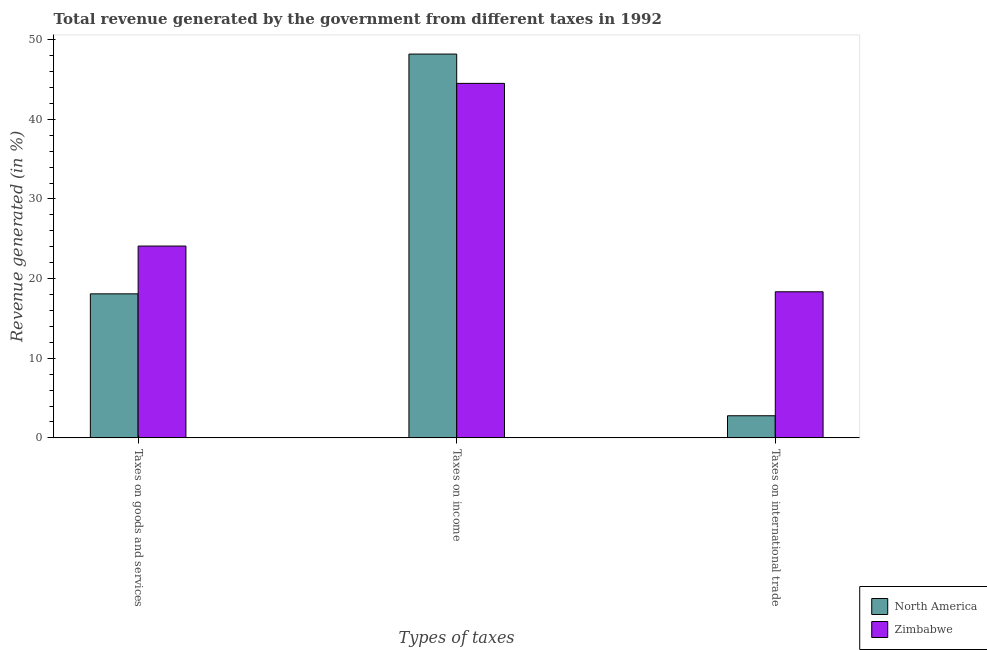Are the number of bars per tick equal to the number of legend labels?
Keep it short and to the point. Yes. Are the number of bars on each tick of the X-axis equal?
Keep it short and to the point. Yes. How many bars are there on the 2nd tick from the left?
Ensure brevity in your answer.  2. How many bars are there on the 1st tick from the right?
Your response must be concise. 2. What is the label of the 1st group of bars from the left?
Offer a very short reply. Taxes on goods and services. What is the percentage of revenue generated by taxes on income in Zimbabwe?
Offer a terse response. 44.51. Across all countries, what is the maximum percentage of revenue generated by taxes on goods and services?
Your answer should be very brief. 24.08. Across all countries, what is the minimum percentage of revenue generated by taxes on income?
Provide a succinct answer. 44.51. In which country was the percentage of revenue generated by taxes on goods and services minimum?
Offer a very short reply. North America. What is the total percentage of revenue generated by tax on international trade in the graph?
Your response must be concise. 21.12. What is the difference between the percentage of revenue generated by taxes on goods and services in Zimbabwe and that in North America?
Provide a succinct answer. 6. What is the difference between the percentage of revenue generated by tax on international trade in Zimbabwe and the percentage of revenue generated by taxes on goods and services in North America?
Make the answer very short. 0.26. What is the average percentage of revenue generated by tax on international trade per country?
Make the answer very short. 10.56. What is the difference between the percentage of revenue generated by taxes on income and percentage of revenue generated by taxes on goods and services in Zimbabwe?
Offer a very short reply. 20.43. What is the ratio of the percentage of revenue generated by tax on international trade in North America to that in Zimbabwe?
Provide a short and direct response. 0.15. Is the percentage of revenue generated by taxes on goods and services in North America less than that in Zimbabwe?
Make the answer very short. Yes. Is the difference between the percentage of revenue generated by tax on international trade in Zimbabwe and North America greater than the difference between the percentage of revenue generated by taxes on income in Zimbabwe and North America?
Offer a terse response. Yes. What is the difference between the highest and the second highest percentage of revenue generated by taxes on income?
Offer a terse response. 3.68. What is the difference between the highest and the lowest percentage of revenue generated by tax on international trade?
Provide a succinct answer. 15.57. Is the sum of the percentage of revenue generated by taxes on income in North America and Zimbabwe greater than the maximum percentage of revenue generated by tax on international trade across all countries?
Offer a very short reply. Yes. What does the 2nd bar from the left in Taxes on international trade represents?
Your answer should be compact. Zimbabwe. What does the 1st bar from the right in Taxes on international trade represents?
Provide a short and direct response. Zimbabwe. How many bars are there?
Your answer should be very brief. 6. What is the difference between two consecutive major ticks on the Y-axis?
Your answer should be very brief. 10. Does the graph contain any zero values?
Your answer should be compact. No. Does the graph contain grids?
Ensure brevity in your answer.  No. Where does the legend appear in the graph?
Offer a terse response. Bottom right. How many legend labels are there?
Your answer should be compact. 2. What is the title of the graph?
Provide a succinct answer. Total revenue generated by the government from different taxes in 1992. Does "Benin" appear as one of the legend labels in the graph?
Offer a terse response. No. What is the label or title of the X-axis?
Your answer should be compact. Types of taxes. What is the label or title of the Y-axis?
Offer a terse response. Revenue generated (in %). What is the Revenue generated (in %) in North America in Taxes on goods and services?
Your response must be concise. 18.08. What is the Revenue generated (in %) of Zimbabwe in Taxes on goods and services?
Your answer should be compact. 24.08. What is the Revenue generated (in %) of North America in Taxes on income?
Your answer should be compact. 48.19. What is the Revenue generated (in %) of Zimbabwe in Taxes on income?
Make the answer very short. 44.51. What is the Revenue generated (in %) of North America in Taxes on international trade?
Provide a succinct answer. 2.78. What is the Revenue generated (in %) in Zimbabwe in Taxes on international trade?
Offer a terse response. 18.34. Across all Types of taxes, what is the maximum Revenue generated (in %) in North America?
Make the answer very short. 48.19. Across all Types of taxes, what is the maximum Revenue generated (in %) in Zimbabwe?
Your answer should be compact. 44.51. Across all Types of taxes, what is the minimum Revenue generated (in %) of North America?
Provide a short and direct response. 2.78. Across all Types of taxes, what is the minimum Revenue generated (in %) in Zimbabwe?
Your answer should be compact. 18.34. What is the total Revenue generated (in %) of North America in the graph?
Offer a very short reply. 69.05. What is the total Revenue generated (in %) of Zimbabwe in the graph?
Offer a terse response. 86.94. What is the difference between the Revenue generated (in %) in North America in Taxes on goods and services and that in Taxes on income?
Your answer should be compact. -30.11. What is the difference between the Revenue generated (in %) of Zimbabwe in Taxes on goods and services and that in Taxes on income?
Your answer should be very brief. -20.43. What is the difference between the Revenue generated (in %) of North America in Taxes on goods and services and that in Taxes on international trade?
Keep it short and to the point. 15.31. What is the difference between the Revenue generated (in %) in Zimbabwe in Taxes on goods and services and that in Taxes on international trade?
Make the answer very short. 5.74. What is the difference between the Revenue generated (in %) in North America in Taxes on income and that in Taxes on international trade?
Keep it short and to the point. 45.41. What is the difference between the Revenue generated (in %) in Zimbabwe in Taxes on income and that in Taxes on international trade?
Keep it short and to the point. 26.17. What is the difference between the Revenue generated (in %) in North America in Taxes on goods and services and the Revenue generated (in %) in Zimbabwe in Taxes on income?
Provide a succinct answer. -26.43. What is the difference between the Revenue generated (in %) of North America in Taxes on goods and services and the Revenue generated (in %) of Zimbabwe in Taxes on international trade?
Offer a terse response. -0.26. What is the difference between the Revenue generated (in %) of North America in Taxes on income and the Revenue generated (in %) of Zimbabwe in Taxes on international trade?
Provide a short and direct response. 29.85. What is the average Revenue generated (in %) of North America per Types of taxes?
Your answer should be compact. 23.02. What is the average Revenue generated (in %) of Zimbabwe per Types of taxes?
Give a very brief answer. 28.98. What is the difference between the Revenue generated (in %) in North America and Revenue generated (in %) in Zimbabwe in Taxes on goods and services?
Keep it short and to the point. -6. What is the difference between the Revenue generated (in %) in North America and Revenue generated (in %) in Zimbabwe in Taxes on income?
Offer a terse response. 3.68. What is the difference between the Revenue generated (in %) of North America and Revenue generated (in %) of Zimbabwe in Taxes on international trade?
Your answer should be very brief. -15.57. What is the ratio of the Revenue generated (in %) in North America in Taxes on goods and services to that in Taxes on income?
Your answer should be compact. 0.38. What is the ratio of the Revenue generated (in %) in Zimbabwe in Taxes on goods and services to that in Taxes on income?
Your answer should be compact. 0.54. What is the ratio of the Revenue generated (in %) of North America in Taxes on goods and services to that in Taxes on international trade?
Your answer should be compact. 6.51. What is the ratio of the Revenue generated (in %) in Zimbabwe in Taxes on goods and services to that in Taxes on international trade?
Offer a terse response. 1.31. What is the ratio of the Revenue generated (in %) of North America in Taxes on income to that in Taxes on international trade?
Your answer should be very brief. 17.36. What is the ratio of the Revenue generated (in %) in Zimbabwe in Taxes on income to that in Taxes on international trade?
Provide a short and direct response. 2.43. What is the difference between the highest and the second highest Revenue generated (in %) in North America?
Your answer should be very brief. 30.11. What is the difference between the highest and the second highest Revenue generated (in %) in Zimbabwe?
Provide a succinct answer. 20.43. What is the difference between the highest and the lowest Revenue generated (in %) in North America?
Provide a succinct answer. 45.41. What is the difference between the highest and the lowest Revenue generated (in %) of Zimbabwe?
Your answer should be compact. 26.17. 